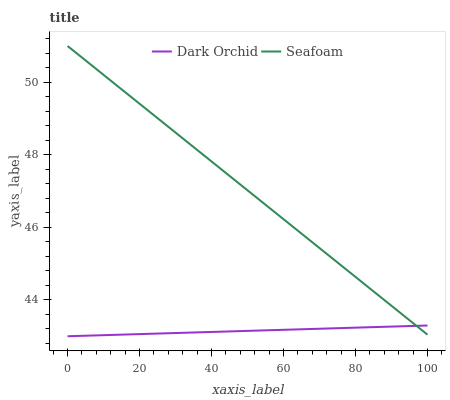Does Dark Orchid have the minimum area under the curve?
Answer yes or no. Yes. Does Seafoam have the maximum area under the curve?
Answer yes or no. Yes. Does Dark Orchid have the maximum area under the curve?
Answer yes or no. No. Is Dark Orchid the smoothest?
Answer yes or no. Yes. Is Seafoam the roughest?
Answer yes or no. Yes. Is Dark Orchid the roughest?
Answer yes or no. No. Does Seafoam have the highest value?
Answer yes or no. Yes. Does Dark Orchid have the highest value?
Answer yes or no. No. Does Seafoam intersect Dark Orchid?
Answer yes or no. Yes. Is Seafoam less than Dark Orchid?
Answer yes or no. No. Is Seafoam greater than Dark Orchid?
Answer yes or no. No. 